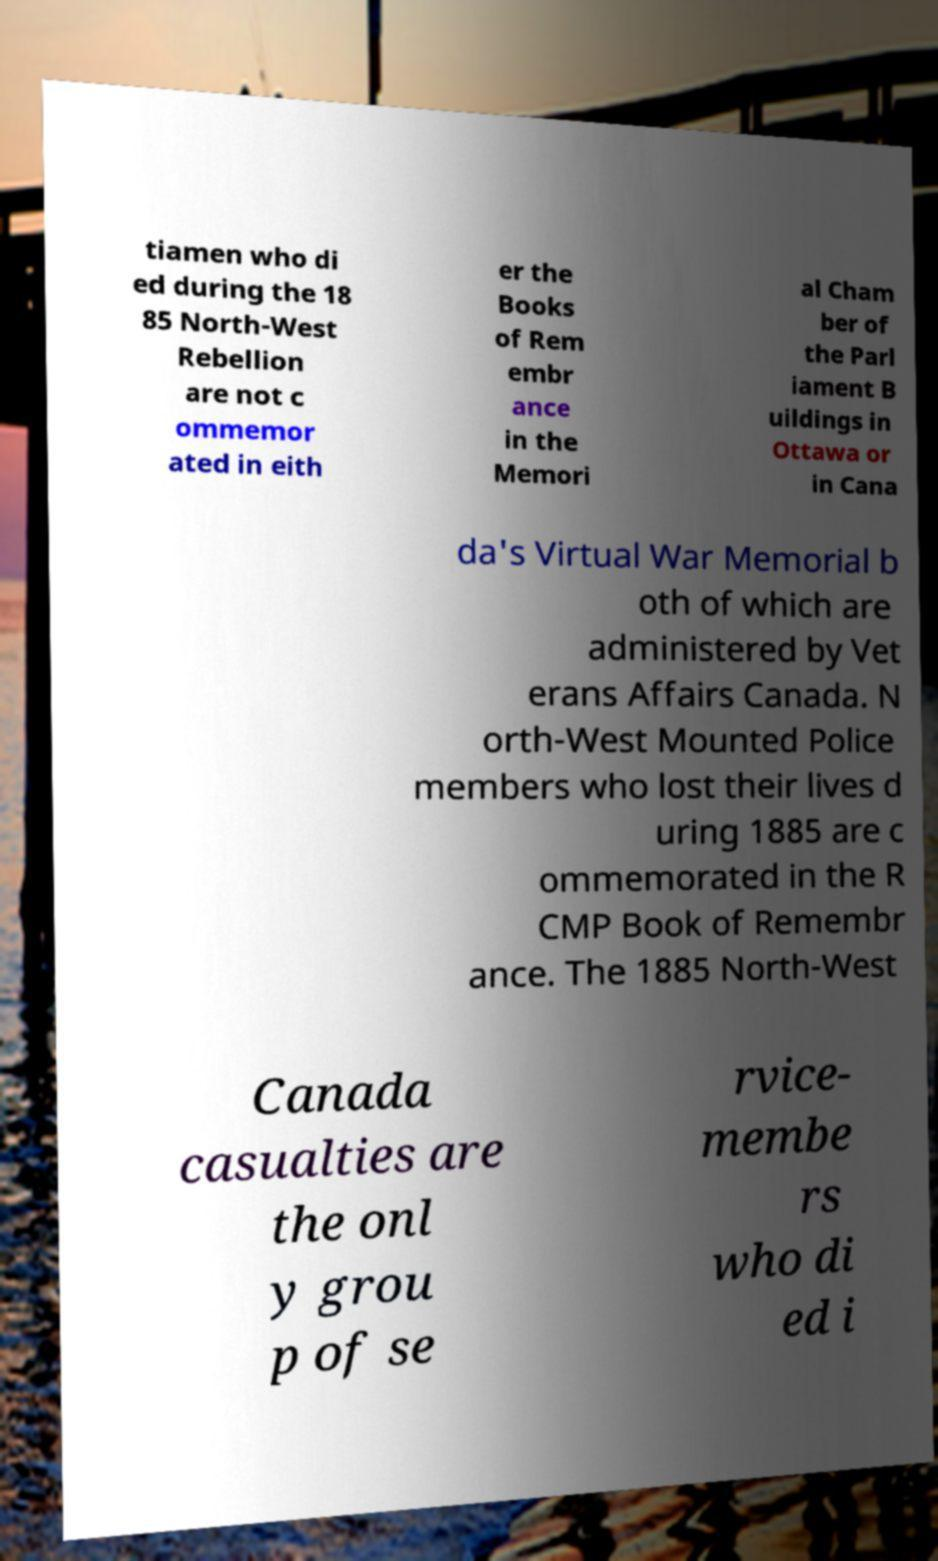Please read and relay the text visible in this image. What does it say? tiamen who di ed during the 18 85 North-West Rebellion are not c ommemor ated in eith er the Books of Rem embr ance in the Memori al Cham ber of the Parl iament B uildings in Ottawa or in Cana da's Virtual War Memorial b oth of which are administered by Vet erans Affairs Canada. N orth-West Mounted Police members who lost their lives d uring 1885 are c ommemorated in the R CMP Book of Remembr ance. The 1885 North-West Canada casualties are the onl y grou p of se rvice- membe rs who di ed i 